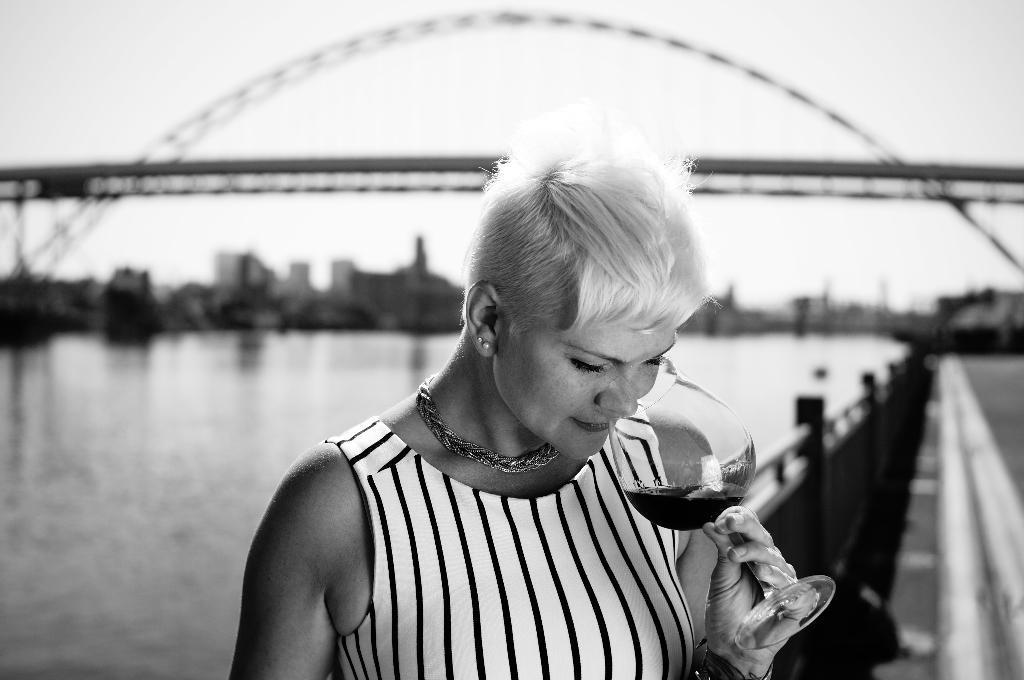Please provide a concise description of this image. This is the picture of a black and white image where we can see a person holding a glass and drinking and in the background, we can see the bridge over the water and there are some buildings and we can see the image is blurred 